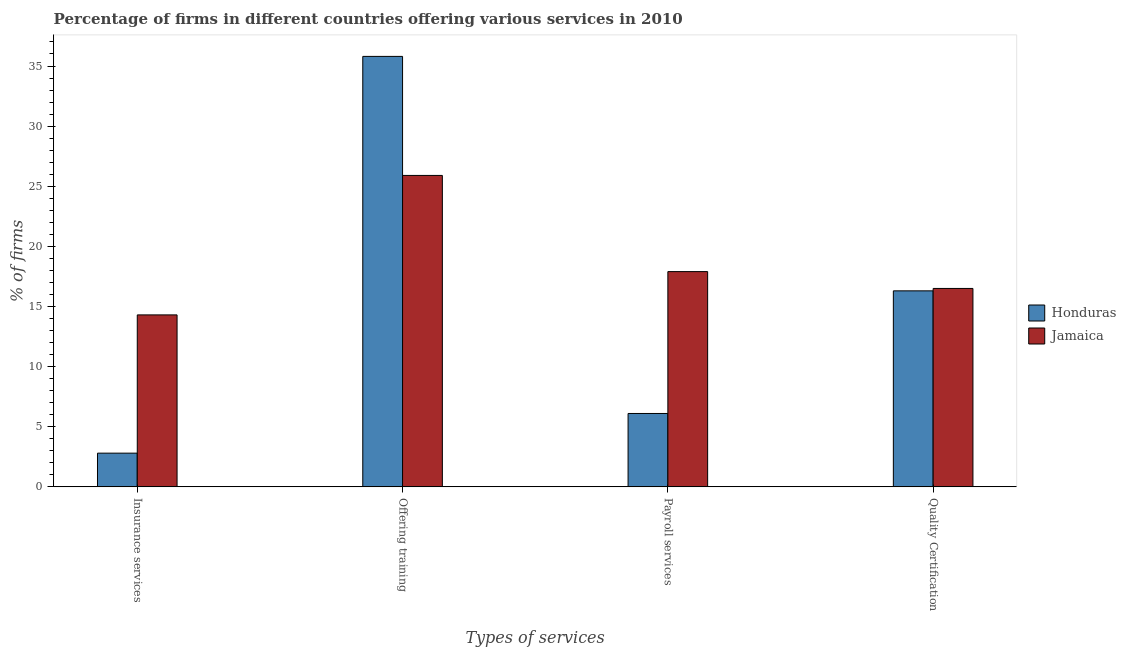How many groups of bars are there?
Ensure brevity in your answer.  4. Are the number of bars per tick equal to the number of legend labels?
Offer a very short reply. Yes. Are the number of bars on each tick of the X-axis equal?
Your response must be concise. Yes. What is the label of the 2nd group of bars from the left?
Your answer should be compact. Offering training. What is the percentage of firms offering payroll services in Jamaica?
Offer a very short reply. 17.9. Across all countries, what is the minimum percentage of firms offering training?
Keep it short and to the point. 25.9. In which country was the percentage of firms offering insurance services maximum?
Provide a succinct answer. Jamaica. In which country was the percentage of firms offering insurance services minimum?
Offer a very short reply. Honduras. What is the total percentage of firms offering quality certification in the graph?
Offer a terse response. 32.8. What is the difference between the percentage of firms offering quality certification in Jamaica and that in Honduras?
Your response must be concise. 0.2. What is the difference between the percentage of firms offering insurance services in Honduras and the percentage of firms offering payroll services in Jamaica?
Offer a terse response. -15.1. What is the average percentage of firms offering training per country?
Give a very brief answer. 30.85. What is the difference between the percentage of firms offering quality certification and percentage of firms offering payroll services in Honduras?
Offer a terse response. 10.2. What is the ratio of the percentage of firms offering quality certification in Honduras to that in Jamaica?
Offer a terse response. 0.99. Is the percentage of firms offering quality certification in Honduras less than that in Jamaica?
Offer a terse response. Yes. Is the difference between the percentage of firms offering training in Honduras and Jamaica greater than the difference between the percentage of firms offering insurance services in Honduras and Jamaica?
Ensure brevity in your answer.  Yes. What is the difference between the highest and the lowest percentage of firms offering training?
Keep it short and to the point. 9.9. Is the sum of the percentage of firms offering payroll services in Honduras and Jamaica greater than the maximum percentage of firms offering quality certification across all countries?
Provide a succinct answer. Yes. What does the 2nd bar from the left in Payroll services represents?
Your answer should be compact. Jamaica. What does the 2nd bar from the right in Payroll services represents?
Your answer should be compact. Honduras. Is it the case that in every country, the sum of the percentage of firms offering insurance services and percentage of firms offering training is greater than the percentage of firms offering payroll services?
Keep it short and to the point. Yes. How many bars are there?
Offer a very short reply. 8. Are all the bars in the graph horizontal?
Your answer should be compact. No. Are the values on the major ticks of Y-axis written in scientific E-notation?
Your answer should be compact. No. Does the graph contain any zero values?
Offer a very short reply. No. Where does the legend appear in the graph?
Give a very brief answer. Center right. How many legend labels are there?
Make the answer very short. 2. How are the legend labels stacked?
Ensure brevity in your answer.  Vertical. What is the title of the graph?
Provide a short and direct response. Percentage of firms in different countries offering various services in 2010. Does "Low income" appear as one of the legend labels in the graph?
Offer a terse response. No. What is the label or title of the X-axis?
Give a very brief answer. Types of services. What is the label or title of the Y-axis?
Make the answer very short. % of firms. What is the % of firms of Honduras in Insurance services?
Ensure brevity in your answer.  2.8. What is the % of firms of Honduras in Offering training?
Provide a succinct answer. 35.8. What is the % of firms of Jamaica in Offering training?
Your response must be concise. 25.9. What is the % of firms of Honduras in Payroll services?
Provide a short and direct response. 6.1. What is the % of firms of Jamaica in Payroll services?
Offer a very short reply. 17.9. Across all Types of services, what is the maximum % of firms in Honduras?
Offer a very short reply. 35.8. Across all Types of services, what is the maximum % of firms of Jamaica?
Offer a very short reply. 25.9. Across all Types of services, what is the minimum % of firms of Honduras?
Make the answer very short. 2.8. What is the total % of firms of Honduras in the graph?
Your response must be concise. 61. What is the total % of firms of Jamaica in the graph?
Your answer should be very brief. 74.6. What is the difference between the % of firms in Honduras in Insurance services and that in Offering training?
Offer a terse response. -33. What is the difference between the % of firms in Jamaica in Insurance services and that in Offering training?
Your answer should be compact. -11.6. What is the difference between the % of firms of Jamaica in Insurance services and that in Payroll services?
Your answer should be very brief. -3.6. What is the difference between the % of firms of Jamaica in Insurance services and that in Quality Certification?
Provide a short and direct response. -2.2. What is the difference between the % of firms in Honduras in Offering training and that in Payroll services?
Your answer should be compact. 29.7. What is the difference between the % of firms in Jamaica in Payroll services and that in Quality Certification?
Keep it short and to the point. 1.4. What is the difference between the % of firms in Honduras in Insurance services and the % of firms in Jamaica in Offering training?
Your response must be concise. -23.1. What is the difference between the % of firms of Honduras in Insurance services and the % of firms of Jamaica in Payroll services?
Your response must be concise. -15.1. What is the difference between the % of firms of Honduras in Insurance services and the % of firms of Jamaica in Quality Certification?
Provide a succinct answer. -13.7. What is the difference between the % of firms of Honduras in Offering training and the % of firms of Jamaica in Quality Certification?
Your answer should be very brief. 19.3. What is the average % of firms in Honduras per Types of services?
Offer a very short reply. 15.25. What is the average % of firms in Jamaica per Types of services?
Give a very brief answer. 18.65. What is the difference between the % of firms of Honduras and % of firms of Jamaica in Insurance services?
Offer a terse response. -11.5. What is the difference between the % of firms in Honduras and % of firms in Jamaica in Quality Certification?
Give a very brief answer. -0.2. What is the ratio of the % of firms in Honduras in Insurance services to that in Offering training?
Your response must be concise. 0.08. What is the ratio of the % of firms of Jamaica in Insurance services to that in Offering training?
Offer a terse response. 0.55. What is the ratio of the % of firms of Honduras in Insurance services to that in Payroll services?
Your answer should be very brief. 0.46. What is the ratio of the % of firms of Jamaica in Insurance services to that in Payroll services?
Your answer should be very brief. 0.8. What is the ratio of the % of firms in Honduras in Insurance services to that in Quality Certification?
Your response must be concise. 0.17. What is the ratio of the % of firms in Jamaica in Insurance services to that in Quality Certification?
Give a very brief answer. 0.87. What is the ratio of the % of firms in Honduras in Offering training to that in Payroll services?
Provide a short and direct response. 5.87. What is the ratio of the % of firms of Jamaica in Offering training to that in Payroll services?
Offer a very short reply. 1.45. What is the ratio of the % of firms in Honduras in Offering training to that in Quality Certification?
Give a very brief answer. 2.2. What is the ratio of the % of firms in Jamaica in Offering training to that in Quality Certification?
Offer a terse response. 1.57. What is the ratio of the % of firms of Honduras in Payroll services to that in Quality Certification?
Your response must be concise. 0.37. What is the ratio of the % of firms in Jamaica in Payroll services to that in Quality Certification?
Keep it short and to the point. 1.08. What is the difference between the highest and the second highest % of firms of Jamaica?
Offer a very short reply. 8. What is the difference between the highest and the lowest % of firms in Honduras?
Your response must be concise. 33. What is the difference between the highest and the lowest % of firms of Jamaica?
Ensure brevity in your answer.  11.6. 